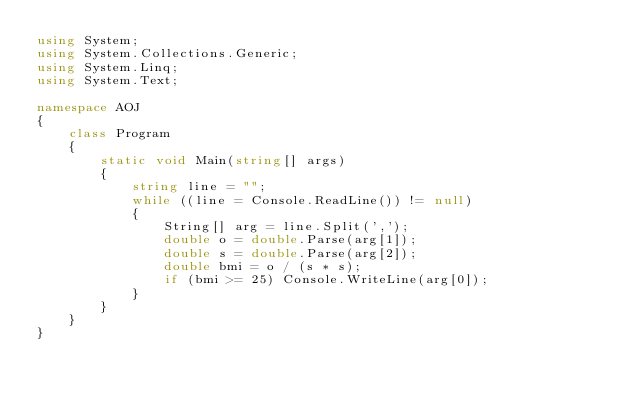<code> <loc_0><loc_0><loc_500><loc_500><_C#_>using System;
using System.Collections.Generic;
using System.Linq;
using System.Text;

namespace AOJ
{
    class Program
    {
        static void Main(string[] args)
        {
            string line = "";
            while ((line = Console.ReadLine()) != null)
            {
                String[] arg = line.Split(',');
                double o = double.Parse(arg[1]);
                double s = double.Parse(arg[2]);
                double bmi = o / (s * s);
                if (bmi >= 25) Console.WriteLine(arg[0]);
            }
        }
    }
}</code> 